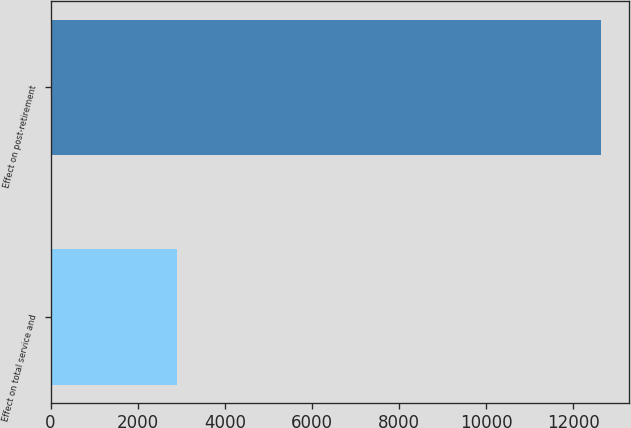<chart> <loc_0><loc_0><loc_500><loc_500><bar_chart><fcel>Effect on total service and<fcel>Effect on post-retirement<nl><fcel>2896<fcel>12636<nl></chart> 